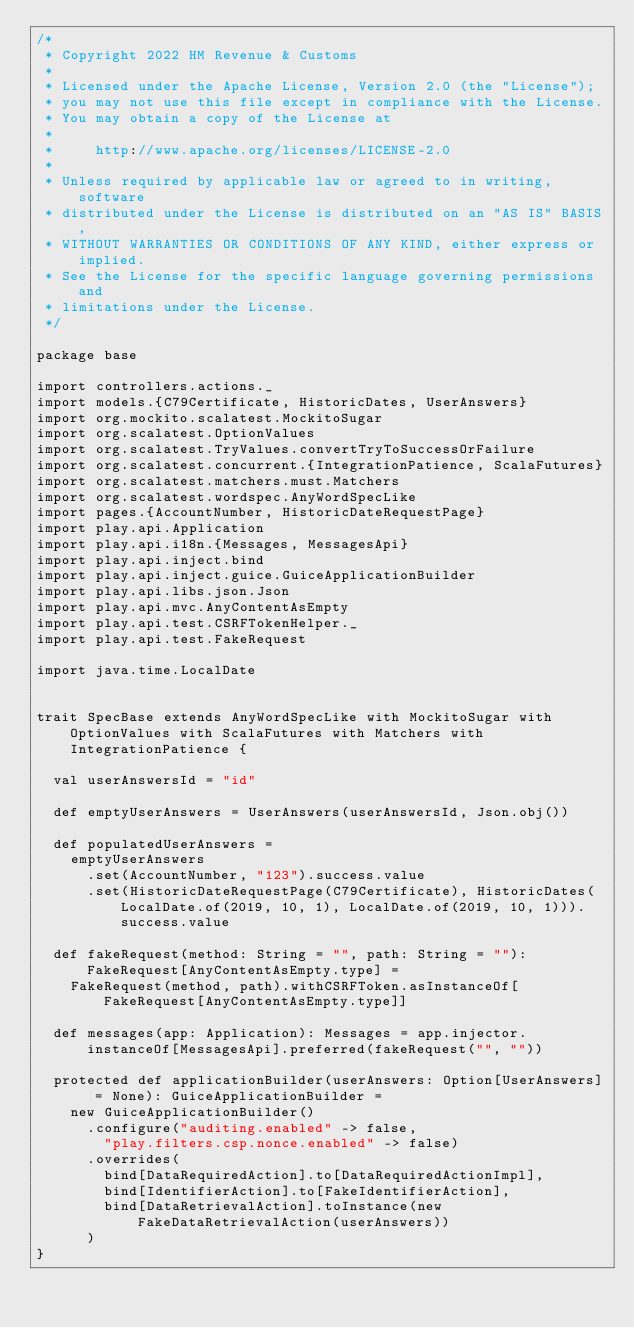<code> <loc_0><loc_0><loc_500><loc_500><_Scala_>/*
 * Copyright 2022 HM Revenue & Customs
 *
 * Licensed under the Apache License, Version 2.0 (the "License");
 * you may not use this file except in compliance with the License.
 * You may obtain a copy of the License at
 *
 *     http://www.apache.org/licenses/LICENSE-2.0
 *
 * Unless required by applicable law or agreed to in writing, software
 * distributed under the License is distributed on an "AS IS" BASIS,
 * WITHOUT WARRANTIES OR CONDITIONS OF ANY KIND, either express or implied.
 * See the License for the specific language governing permissions and
 * limitations under the License.
 */

package base

import controllers.actions._
import models.{C79Certificate, HistoricDates, UserAnswers}
import org.mockito.scalatest.MockitoSugar
import org.scalatest.OptionValues
import org.scalatest.TryValues.convertTryToSuccessOrFailure
import org.scalatest.concurrent.{IntegrationPatience, ScalaFutures}
import org.scalatest.matchers.must.Matchers
import org.scalatest.wordspec.AnyWordSpecLike
import pages.{AccountNumber, HistoricDateRequestPage}
import play.api.Application
import play.api.i18n.{Messages, MessagesApi}
import play.api.inject.bind
import play.api.inject.guice.GuiceApplicationBuilder
import play.api.libs.json.Json
import play.api.mvc.AnyContentAsEmpty
import play.api.test.CSRFTokenHelper._
import play.api.test.FakeRequest

import java.time.LocalDate


trait SpecBase extends AnyWordSpecLike with MockitoSugar with OptionValues with ScalaFutures with Matchers with IntegrationPatience {

  val userAnswersId = "id"

  def emptyUserAnswers = UserAnswers(userAnswersId, Json.obj())

  def populatedUserAnswers =
    emptyUserAnswers
      .set(AccountNumber, "123").success.value
      .set(HistoricDateRequestPage(C79Certificate), HistoricDates(LocalDate.of(2019, 10, 1), LocalDate.of(2019, 10, 1))).success.value

  def fakeRequest(method: String = "", path: String = ""): FakeRequest[AnyContentAsEmpty.type] =
    FakeRequest(method, path).withCSRFToken.asInstanceOf[FakeRequest[AnyContentAsEmpty.type]]

  def messages(app: Application): Messages = app.injector.instanceOf[MessagesApi].preferred(fakeRequest("", ""))

  protected def applicationBuilder(userAnswers: Option[UserAnswers] = None): GuiceApplicationBuilder =
    new GuiceApplicationBuilder()
      .configure("auditing.enabled" -> false,
        "play.filters.csp.nonce.enabled" -> false)
      .overrides(
        bind[DataRequiredAction].to[DataRequiredActionImpl],
        bind[IdentifierAction].to[FakeIdentifierAction],
        bind[DataRetrievalAction].toInstance(new FakeDataRetrievalAction(userAnswers))
      )
}
</code> 